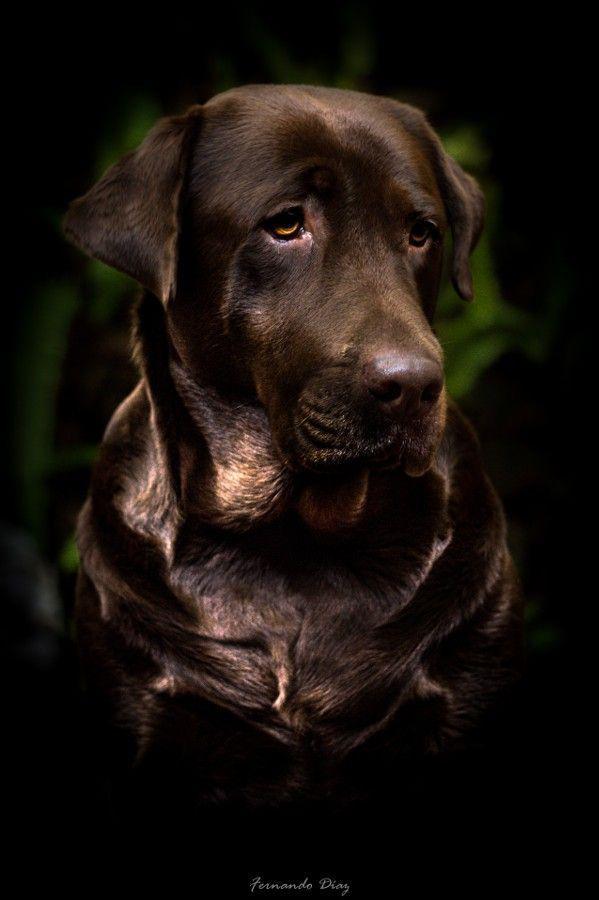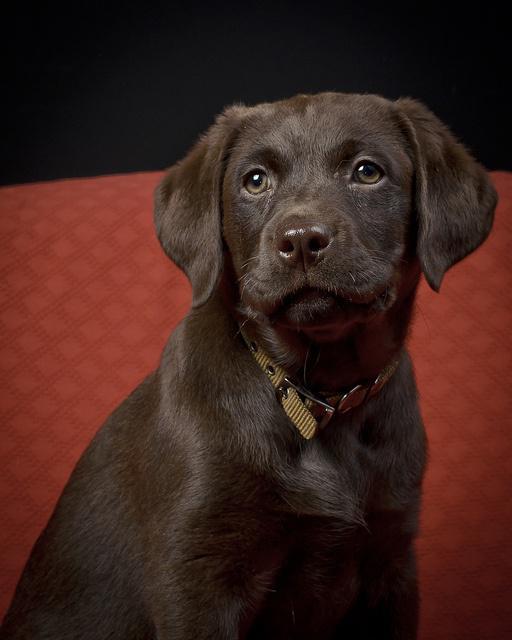The first image is the image on the left, the second image is the image on the right. For the images shown, is this caption "An image shows one young dog looking upward and to one side." true? Answer yes or no. Yes. The first image is the image on the left, the second image is the image on the right. For the images shown, is this caption "The dog in the image on the left is not looking at the camera." true? Answer yes or no. Yes. 